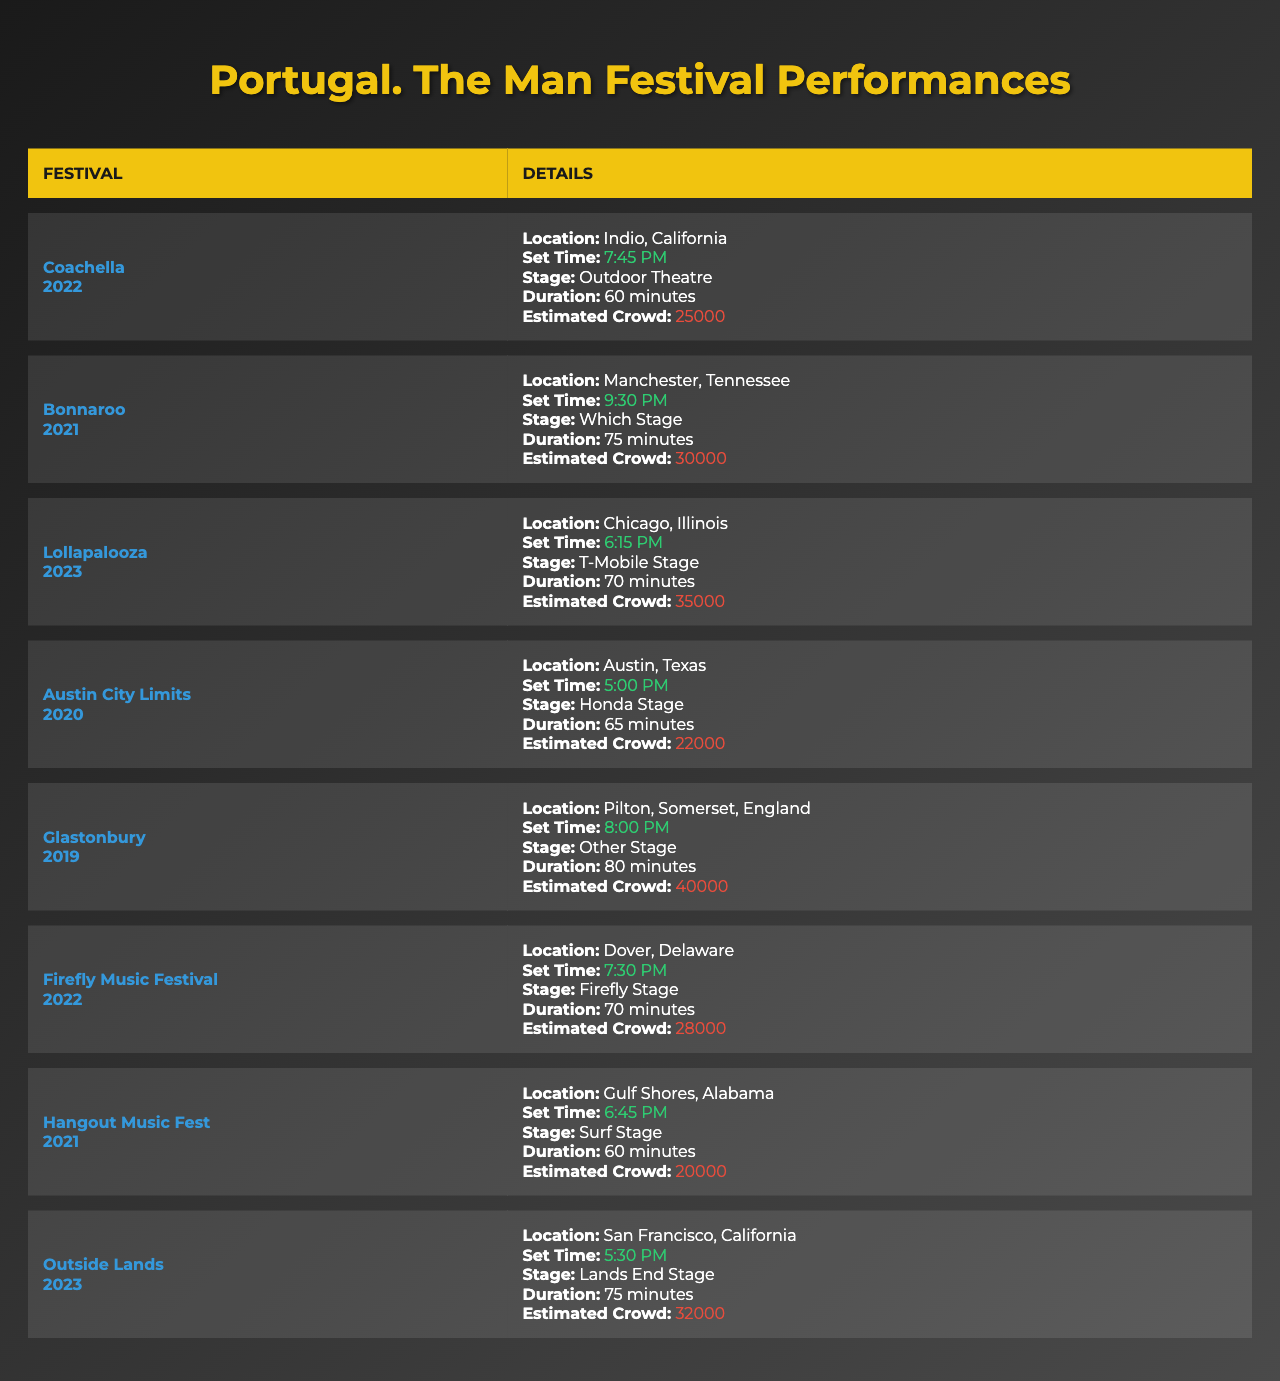What is the location of the Bonnaroo festival? The table lists Bonnaroo as being held in Manchester, Tennessee.
Answer: Manchester, Tennessee How long was Portugal. The Man's set at the Glastonbury festival? The duration of Portugal. The Man's set at Glastonbury is listed as 80 minutes.
Answer: 80 minutes Which festival had the largest estimated crowd for Portugal. The Man's performance? By comparing the crowd size estimates, Glastonbury has the largest size at 40,000.
Answer: 40,000 What is the set time for Portugal. The Man at Lollapalooza? The set time is indicated as 6:15 PM for the Lollapalooza festival.
Answer: 6:15 PM If you add the set times for the performances at Coachella and Firefly Music Festival, what total time do you get? Coachella's set time is 7:45 PM and Firefly's is 7:30 PM. Adding these does not yield a direct sum of times, as they are specific times, not durations. However, the combined duration is (60 + 70 = 130 minutes or 2 hours and 10 minutes).
Answer: 130 minutes Did Portugal. The Man perform at Austin City Limits after 2020? The performance year for Austin City Limits is 2020, so they did not perform there after this year.
Answer: No What is the average duration of Portugal. The Man's performances across the festivals listed? The total duration from the table is 70 + 75 + 60 + 65 + 80 + 70 + 60 + 75, which equals 585 minutes. Divided by 8 performances gives an average of 73.125 minutes.
Answer: 73.125 minutes Which festival features Portugal. The Man performing at 6:45 PM? The performance time of 6:45 PM is for the Hangout Music Fest in 2021.
Answer: Hangout Music Fest Calculate the difference in estimated crowd sizes between Firefly Music Festival and Outside Lands. Firefly's estimated crowd size is 28,000 and Outside Lands is 32,000. The difference is 32,000 - 28,000 = 4,000.
Answer: 4,000 Have Portugal. The Man ever played at the Honda Stage? Looking at the table, they performed at Honda Stage in 2020 for Austin City Limits.
Answer: Yes 